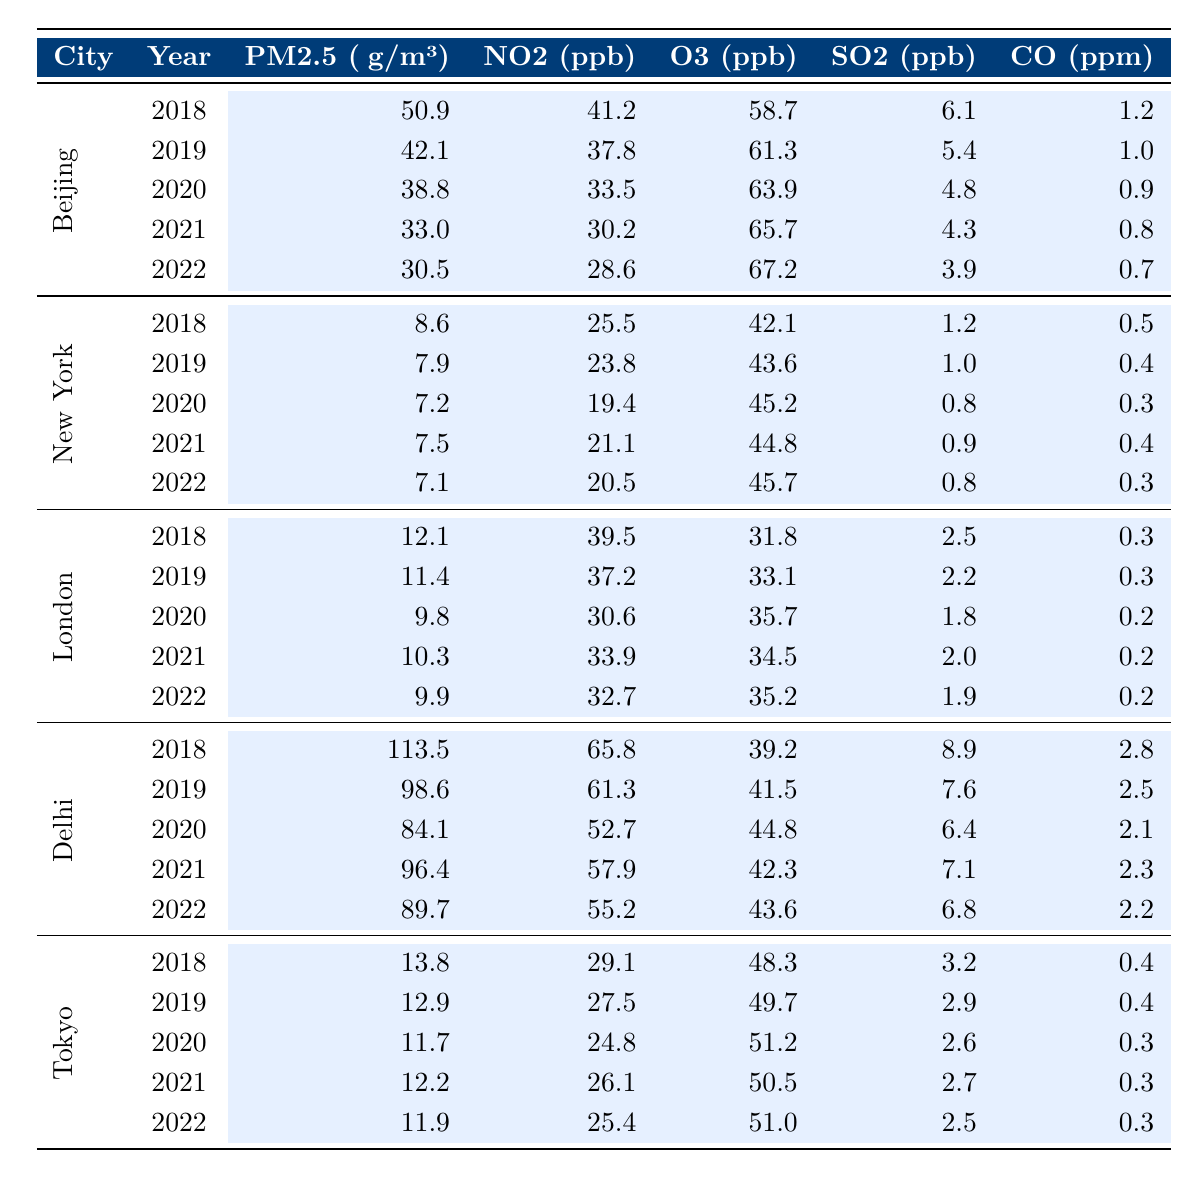What is the PM2.5 level in Delhi in 2020? From the table, I find the row for Delhi and the year 2020. The PM2.5 level listed is 84.1 μg/m³.
Answer: 84.1 μg/m³ Which city had the highest NO2 levels in 2018? By examining the NO2 values for each city in 2018, I see that Delhi had the highest level at 65.8 ppb.
Answer: Delhi What was the average O3 level in London over the five years? The O3 levels in London are 31.8, 33.1, 35.7, 34.5, and 35.2 ppb. Adding these gives 170.3, and the average is 170.3 / 5 = 34.06.
Answer: 34.06 ppb Did Beijing's PM2.5 levels decrease every year from 2018 to 2022? I check the PM2.5 values for Beijing from 2018 to 2022: 50.9, 42.1, 38.8, 33.0, and 30.5 μg/m³. Each year shows a decrease; therefore, the answer is yes.
Answer: Yes What is the difference in CO levels between Delhi in 2018 and New York in 2022? The CO level in Delhi in 2018 is 2.8 ppm, and in New York in 2022, it is 0.3 ppm. The difference is 2.8 - 0.3 = 2.5 ppm.
Answer: 2.5 ppm Which city consistently had the lowest PM2.5 levels over the five years? I check the PM2.5 levels for each city over the years: New York shows 8.6, 7.9, 7.2, 7.5, and 7.1 μg/m³. This is lower than all other cities across the years.
Answer: New York What was the highest SO2 level recorded in Tokyo and in which year? Reviewing Tokyo's SO2 levels, I find values of 3.2, 2.9, 2.6, 2.7, and 2.5 ppb from 2018 to 2022. The highest value is 3.2 ppb in 2018.
Answer: 3.2 ppb in 2018 How much did PM2.5 levels decrease in Beijing from 2018 to 2022? The PM2.5 level in Beijing was 50.9 μg/m³ in 2018 and 30.5 μg/m³ in 2022. The decrease is 50.9 - 30.5 = 20.4 μg/m³.
Answer: 20.4 μg/m³ Was there any year in which the NO2 level in London exceeded 40 ppb? The NO2 levels in London from 2018 to 2022 are 39.5, 37.2, 30.6, 33.9, and 32.7 ppb. None of these exceed 40 ppb, thus the answer is no.
Answer: No What was the average CO level in Delhi from 2018 to 2022? The CO levels in Delhi are 2.8, 2.5, 2.1, 2.3, and 2.2 ppm. Summing these gives 12.9, and the average is 12.9 / 5 = 2.58 ppm.
Answer: 2.58 ppm 